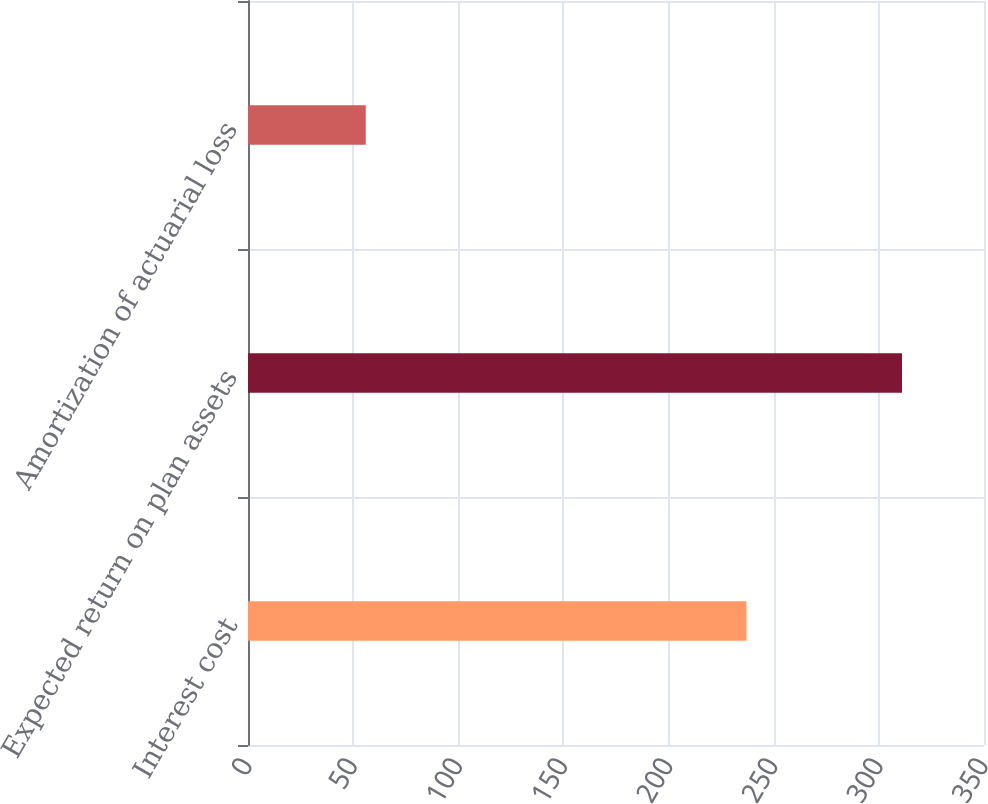Convert chart. <chart><loc_0><loc_0><loc_500><loc_500><bar_chart><fcel>Interest cost<fcel>Expected return on plan assets<fcel>Amortization of actuarial loss<nl><fcel>237<fcel>311<fcel>56<nl></chart> 